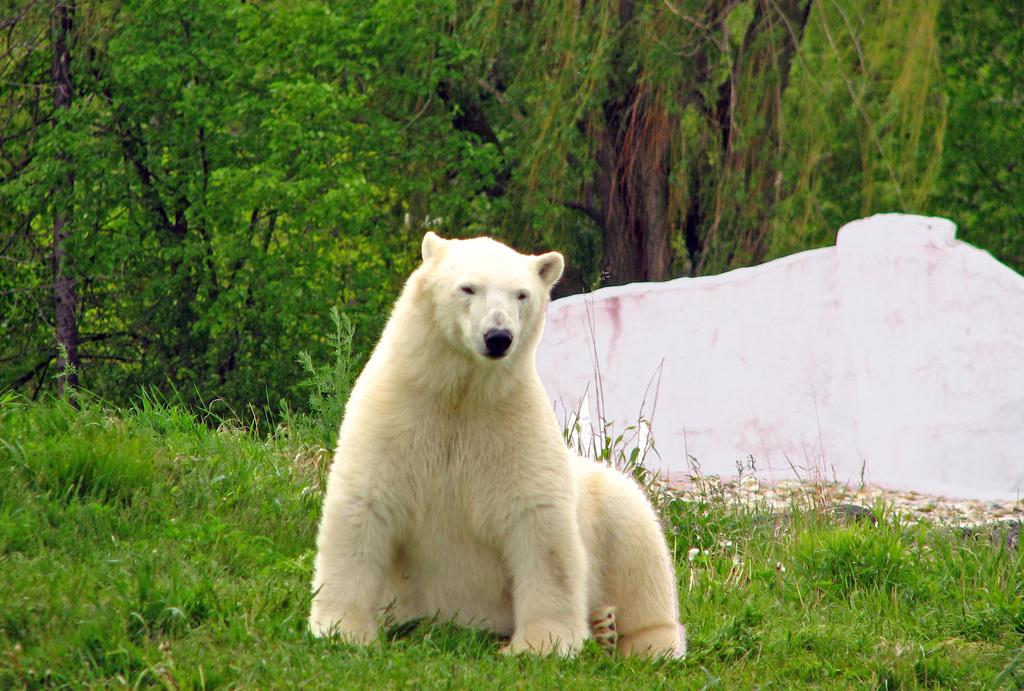What animal is present in the image? There is a bear in the image. What is the bear doing in the image? The bear is sitting on the grass. What type of vegetation can be seen in the image? There are trees visible in the image. What shade of lip polish is the bear wearing in the image? There is no lip polish present in the image, as bears do not wear makeup. 